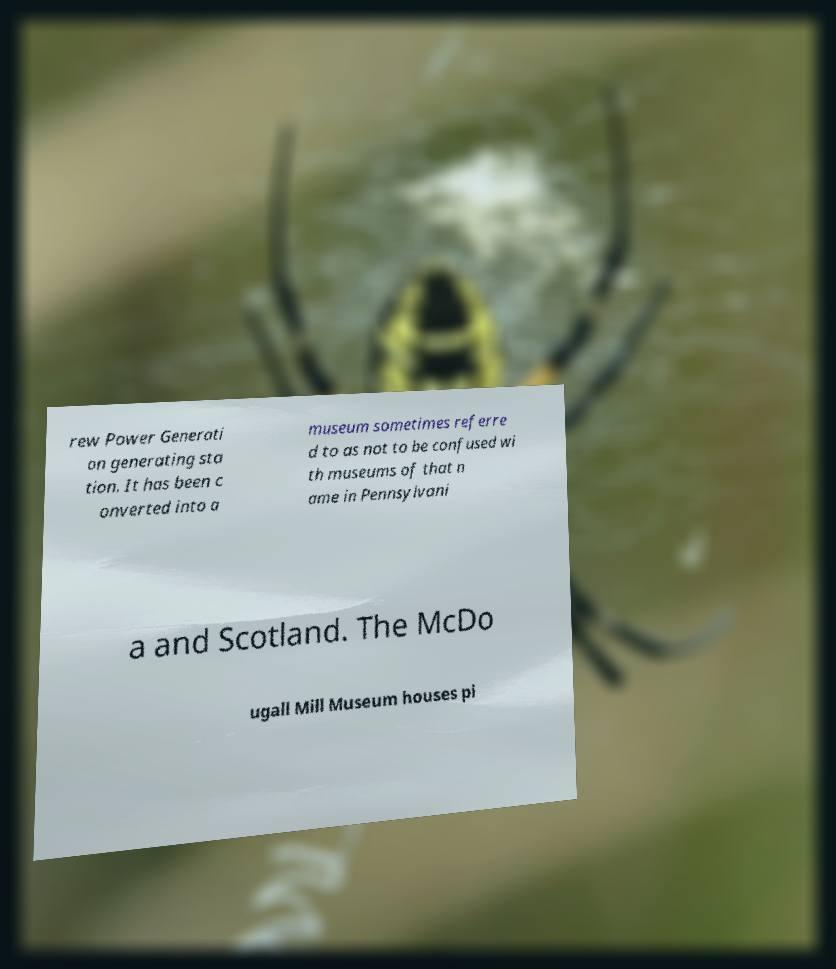There's text embedded in this image that I need extracted. Can you transcribe it verbatim? rew Power Generati on generating sta tion. It has been c onverted into a museum sometimes referre d to as not to be confused wi th museums of that n ame in Pennsylvani a and Scotland. The McDo ugall Mill Museum houses pi 